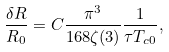Convert formula to latex. <formula><loc_0><loc_0><loc_500><loc_500>\frac { \delta R } { R _ { 0 } } = C \frac { \pi ^ { 3 } } { 1 6 8 \zeta ( 3 ) } \frac { 1 } { \tau T _ { c 0 } } ,</formula> 